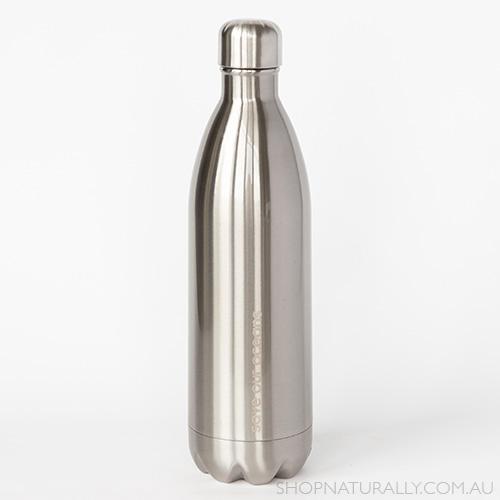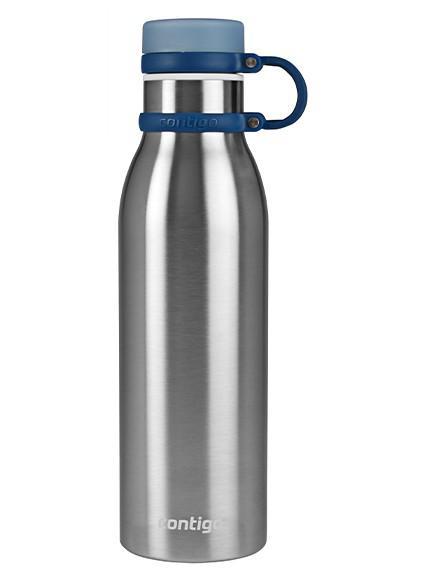The first image is the image on the left, the second image is the image on the right. Evaluate the accuracy of this statement regarding the images: "There are stainless steel water bottles that are all solid colored.". Is it true? Answer yes or no. Yes. 